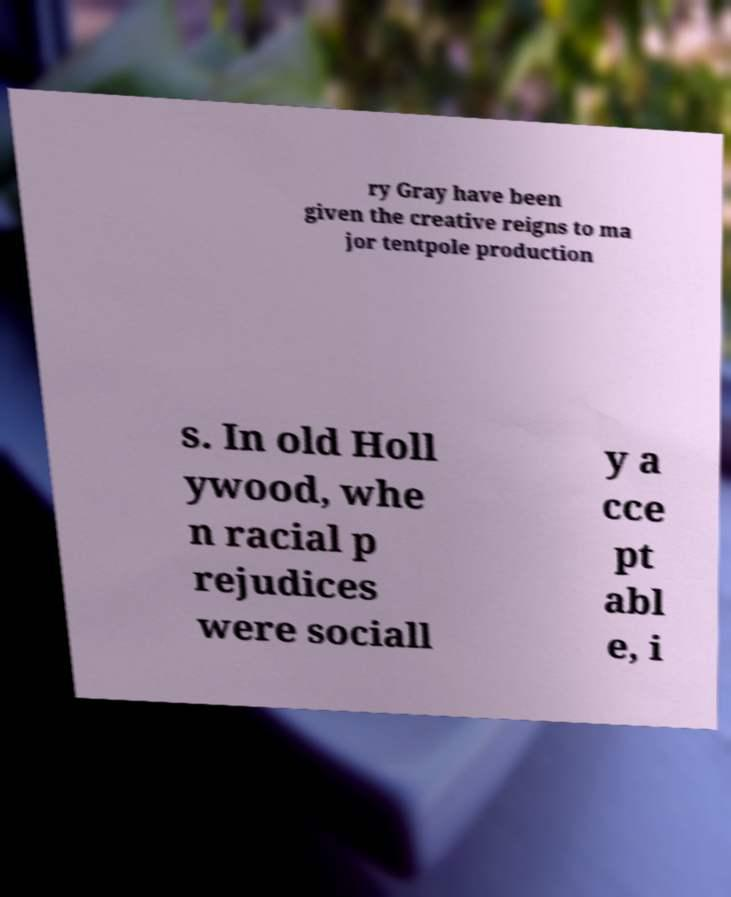What messages or text are displayed in this image? I need them in a readable, typed format. ry Gray have been given the creative reigns to ma jor tentpole production s. In old Holl ywood, whe n racial p rejudices were sociall y a cce pt abl e, i 